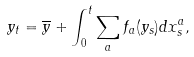<formula> <loc_0><loc_0><loc_500><loc_500>y _ { t } = \overline { y } + \int _ { 0 } ^ { t } \sum _ { a } f _ { a } ( y _ { s } ) d x ^ { a } _ { s } ,</formula> 